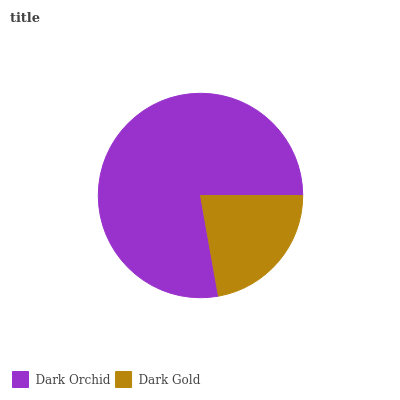Is Dark Gold the minimum?
Answer yes or no. Yes. Is Dark Orchid the maximum?
Answer yes or no. Yes. Is Dark Gold the maximum?
Answer yes or no. No. Is Dark Orchid greater than Dark Gold?
Answer yes or no. Yes. Is Dark Gold less than Dark Orchid?
Answer yes or no. Yes. Is Dark Gold greater than Dark Orchid?
Answer yes or no. No. Is Dark Orchid less than Dark Gold?
Answer yes or no. No. Is Dark Orchid the high median?
Answer yes or no. Yes. Is Dark Gold the low median?
Answer yes or no. Yes. Is Dark Gold the high median?
Answer yes or no. No. Is Dark Orchid the low median?
Answer yes or no. No. 